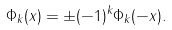<formula> <loc_0><loc_0><loc_500><loc_500>\Phi _ { k } ( x ) = \pm ( - 1 ) ^ { k } \Phi _ { k } ( - x ) .</formula> 